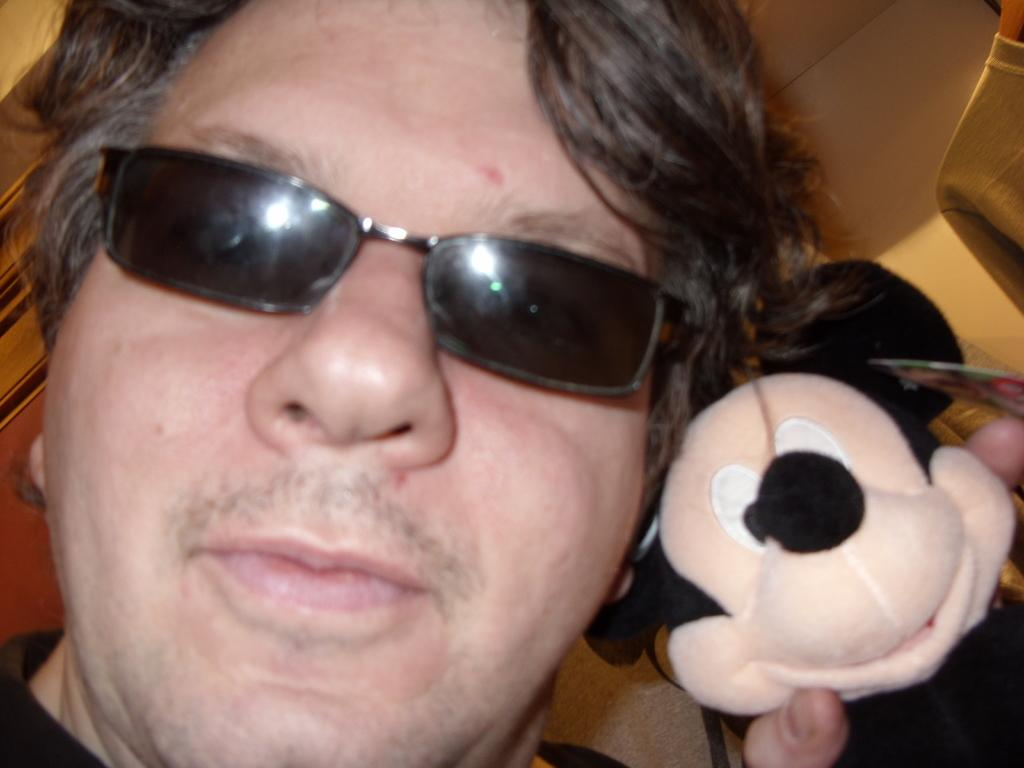What is present in the image? There is a man and a toy in the image. Can you describe the man in the image? The facts provided do not give any specific details about the man's appearance or actions. What type of toy is in the image? The facts provided do not give any specific details about the toy. What type of loaf is the man holding in the image? There is no loaf present in the image; it only features a man and a toy. How does the man's throat look like in the image? The facts provided do not give any specific details about the man's throat. 